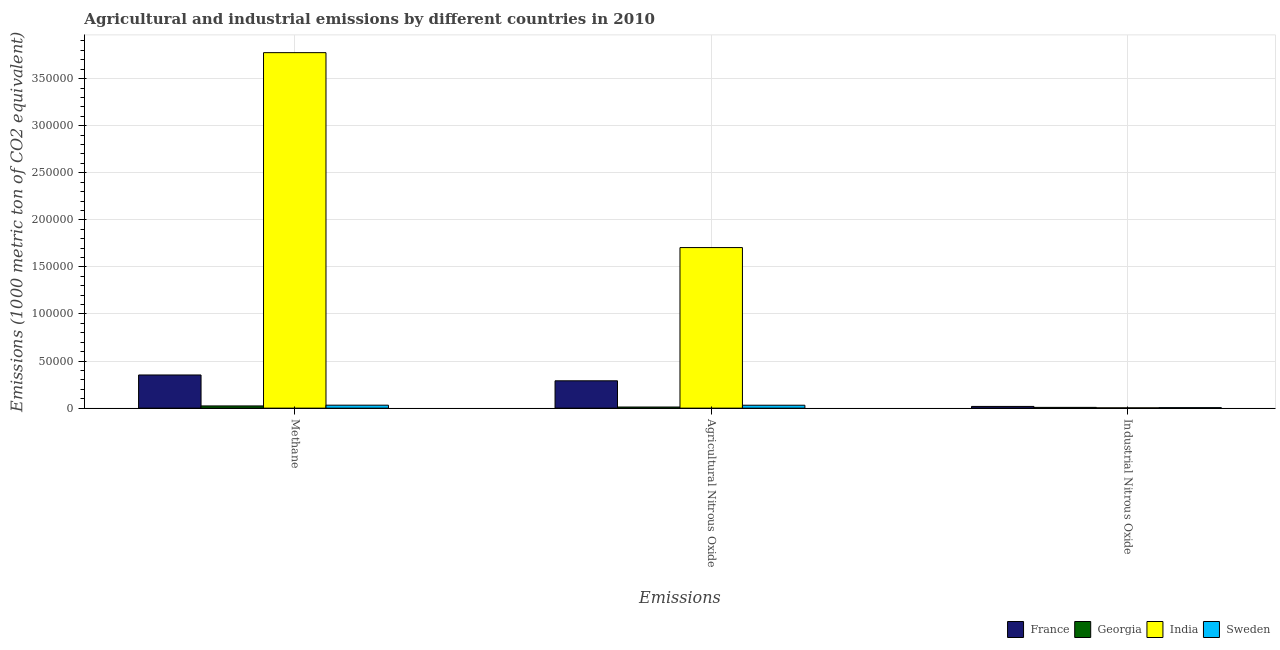How many different coloured bars are there?
Ensure brevity in your answer.  4. How many groups of bars are there?
Your answer should be compact. 3. Are the number of bars on each tick of the X-axis equal?
Offer a very short reply. Yes. How many bars are there on the 1st tick from the left?
Your response must be concise. 4. What is the label of the 2nd group of bars from the left?
Your answer should be compact. Agricultural Nitrous Oxide. What is the amount of agricultural nitrous oxide emissions in Georgia?
Your response must be concise. 1195.6. Across all countries, what is the maximum amount of methane emissions?
Provide a succinct answer. 3.78e+05. Across all countries, what is the minimum amount of industrial nitrous oxide emissions?
Your answer should be compact. 314.9. In which country was the amount of agricultural nitrous oxide emissions minimum?
Keep it short and to the point. Georgia. What is the total amount of agricultural nitrous oxide emissions in the graph?
Offer a very short reply. 2.04e+05. What is the difference between the amount of agricultural nitrous oxide emissions in Sweden and that in France?
Offer a very short reply. -2.59e+04. What is the difference between the amount of agricultural nitrous oxide emissions in Georgia and the amount of industrial nitrous oxide emissions in France?
Give a very brief answer. -633.2. What is the average amount of methane emissions per country?
Offer a terse response. 1.05e+05. What is the difference between the amount of methane emissions and amount of agricultural nitrous oxide emissions in India?
Your answer should be very brief. 2.07e+05. In how many countries, is the amount of industrial nitrous oxide emissions greater than 370000 metric ton?
Make the answer very short. 0. What is the ratio of the amount of methane emissions in France to that in Sweden?
Your answer should be very brief. 11.21. Is the difference between the amount of methane emissions in Sweden and India greater than the difference between the amount of industrial nitrous oxide emissions in Sweden and India?
Keep it short and to the point. No. What is the difference between the highest and the second highest amount of methane emissions?
Give a very brief answer. 3.42e+05. What is the difference between the highest and the lowest amount of industrial nitrous oxide emissions?
Make the answer very short. 1513.9. In how many countries, is the amount of industrial nitrous oxide emissions greater than the average amount of industrial nitrous oxide emissions taken over all countries?
Your response must be concise. 1. How many bars are there?
Offer a very short reply. 12. Are the values on the major ticks of Y-axis written in scientific E-notation?
Your response must be concise. No. Where does the legend appear in the graph?
Give a very brief answer. Bottom right. What is the title of the graph?
Offer a very short reply. Agricultural and industrial emissions by different countries in 2010. What is the label or title of the X-axis?
Offer a terse response. Emissions. What is the label or title of the Y-axis?
Provide a short and direct response. Emissions (1000 metric ton of CO2 equivalent). What is the Emissions (1000 metric ton of CO2 equivalent) of France in Methane?
Offer a very short reply. 3.52e+04. What is the Emissions (1000 metric ton of CO2 equivalent) of Georgia in Methane?
Offer a very short reply. 2363.1. What is the Emissions (1000 metric ton of CO2 equivalent) in India in Methane?
Offer a very short reply. 3.78e+05. What is the Emissions (1000 metric ton of CO2 equivalent) of Sweden in Methane?
Your answer should be very brief. 3144.6. What is the Emissions (1000 metric ton of CO2 equivalent) of France in Agricultural Nitrous Oxide?
Give a very brief answer. 2.90e+04. What is the Emissions (1000 metric ton of CO2 equivalent) in Georgia in Agricultural Nitrous Oxide?
Keep it short and to the point. 1195.6. What is the Emissions (1000 metric ton of CO2 equivalent) of India in Agricultural Nitrous Oxide?
Ensure brevity in your answer.  1.71e+05. What is the Emissions (1000 metric ton of CO2 equivalent) of Sweden in Agricultural Nitrous Oxide?
Provide a succinct answer. 3101. What is the Emissions (1000 metric ton of CO2 equivalent) in France in Industrial Nitrous Oxide?
Ensure brevity in your answer.  1828.8. What is the Emissions (1000 metric ton of CO2 equivalent) of Georgia in Industrial Nitrous Oxide?
Provide a short and direct response. 820.8. What is the Emissions (1000 metric ton of CO2 equivalent) in India in Industrial Nitrous Oxide?
Keep it short and to the point. 314.9. What is the Emissions (1000 metric ton of CO2 equivalent) of Sweden in Industrial Nitrous Oxide?
Your response must be concise. 536.2. Across all Emissions, what is the maximum Emissions (1000 metric ton of CO2 equivalent) in France?
Your answer should be very brief. 3.52e+04. Across all Emissions, what is the maximum Emissions (1000 metric ton of CO2 equivalent) of Georgia?
Keep it short and to the point. 2363.1. Across all Emissions, what is the maximum Emissions (1000 metric ton of CO2 equivalent) of India?
Provide a succinct answer. 3.78e+05. Across all Emissions, what is the maximum Emissions (1000 metric ton of CO2 equivalent) of Sweden?
Your answer should be compact. 3144.6. Across all Emissions, what is the minimum Emissions (1000 metric ton of CO2 equivalent) in France?
Provide a succinct answer. 1828.8. Across all Emissions, what is the minimum Emissions (1000 metric ton of CO2 equivalent) of Georgia?
Your response must be concise. 820.8. Across all Emissions, what is the minimum Emissions (1000 metric ton of CO2 equivalent) in India?
Make the answer very short. 314.9. Across all Emissions, what is the minimum Emissions (1000 metric ton of CO2 equivalent) in Sweden?
Make the answer very short. 536.2. What is the total Emissions (1000 metric ton of CO2 equivalent) of France in the graph?
Your answer should be compact. 6.61e+04. What is the total Emissions (1000 metric ton of CO2 equivalent) in Georgia in the graph?
Ensure brevity in your answer.  4379.5. What is the total Emissions (1000 metric ton of CO2 equivalent) of India in the graph?
Keep it short and to the point. 5.48e+05. What is the total Emissions (1000 metric ton of CO2 equivalent) of Sweden in the graph?
Your answer should be compact. 6781.8. What is the difference between the Emissions (1000 metric ton of CO2 equivalent) in France in Methane and that in Agricultural Nitrous Oxide?
Your response must be concise. 6198.9. What is the difference between the Emissions (1000 metric ton of CO2 equivalent) in Georgia in Methane and that in Agricultural Nitrous Oxide?
Offer a terse response. 1167.5. What is the difference between the Emissions (1000 metric ton of CO2 equivalent) of India in Methane and that in Agricultural Nitrous Oxide?
Keep it short and to the point. 2.07e+05. What is the difference between the Emissions (1000 metric ton of CO2 equivalent) of Sweden in Methane and that in Agricultural Nitrous Oxide?
Provide a succinct answer. 43.6. What is the difference between the Emissions (1000 metric ton of CO2 equivalent) of France in Methane and that in Industrial Nitrous Oxide?
Give a very brief answer. 3.34e+04. What is the difference between the Emissions (1000 metric ton of CO2 equivalent) in Georgia in Methane and that in Industrial Nitrous Oxide?
Your answer should be very brief. 1542.3. What is the difference between the Emissions (1000 metric ton of CO2 equivalent) of India in Methane and that in Industrial Nitrous Oxide?
Your answer should be very brief. 3.77e+05. What is the difference between the Emissions (1000 metric ton of CO2 equivalent) in Sweden in Methane and that in Industrial Nitrous Oxide?
Keep it short and to the point. 2608.4. What is the difference between the Emissions (1000 metric ton of CO2 equivalent) of France in Agricultural Nitrous Oxide and that in Industrial Nitrous Oxide?
Your answer should be very brief. 2.72e+04. What is the difference between the Emissions (1000 metric ton of CO2 equivalent) in Georgia in Agricultural Nitrous Oxide and that in Industrial Nitrous Oxide?
Provide a succinct answer. 374.8. What is the difference between the Emissions (1000 metric ton of CO2 equivalent) of India in Agricultural Nitrous Oxide and that in Industrial Nitrous Oxide?
Make the answer very short. 1.70e+05. What is the difference between the Emissions (1000 metric ton of CO2 equivalent) of Sweden in Agricultural Nitrous Oxide and that in Industrial Nitrous Oxide?
Your response must be concise. 2564.8. What is the difference between the Emissions (1000 metric ton of CO2 equivalent) in France in Methane and the Emissions (1000 metric ton of CO2 equivalent) in Georgia in Agricultural Nitrous Oxide?
Offer a terse response. 3.40e+04. What is the difference between the Emissions (1000 metric ton of CO2 equivalent) in France in Methane and the Emissions (1000 metric ton of CO2 equivalent) in India in Agricultural Nitrous Oxide?
Give a very brief answer. -1.35e+05. What is the difference between the Emissions (1000 metric ton of CO2 equivalent) of France in Methane and the Emissions (1000 metric ton of CO2 equivalent) of Sweden in Agricultural Nitrous Oxide?
Give a very brief answer. 3.21e+04. What is the difference between the Emissions (1000 metric ton of CO2 equivalent) of Georgia in Methane and the Emissions (1000 metric ton of CO2 equivalent) of India in Agricultural Nitrous Oxide?
Provide a succinct answer. -1.68e+05. What is the difference between the Emissions (1000 metric ton of CO2 equivalent) in Georgia in Methane and the Emissions (1000 metric ton of CO2 equivalent) in Sweden in Agricultural Nitrous Oxide?
Provide a short and direct response. -737.9. What is the difference between the Emissions (1000 metric ton of CO2 equivalent) in India in Methane and the Emissions (1000 metric ton of CO2 equivalent) in Sweden in Agricultural Nitrous Oxide?
Offer a terse response. 3.74e+05. What is the difference between the Emissions (1000 metric ton of CO2 equivalent) of France in Methane and the Emissions (1000 metric ton of CO2 equivalent) of Georgia in Industrial Nitrous Oxide?
Offer a terse response. 3.44e+04. What is the difference between the Emissions (1000 metric ton of CO2 equivalent) in France in Methane and the Emissions (1000 metric ton of CO2 equivalent) in India in Industrial Nitrous Oxide?
Offer a very short reply. 3.49e+04. What is the difference between the Emissions (1000 metric ton of CO2 equivalent) in France in Methane and the Emissions (1000 metric ton of CO2 equivalent) in Sweden in Industrial Nitrous Oxide?
Keep it short and to the point. 3.47e+04. What is the difference between the Emissions (1000 metric ton of CO2 equivalent) in Georgia in Methane and the Emissions (1000 metric ton of CO2 equivalent) in India in Industrial Nitrous Oxide?
Offer a very short reply. 2048.2. What is the difference between the Emissions (1000 metric ton of CO2 equivalent) of Georgia in Methane and the Emissions (1000 metric ton of CO2 equivalent) of Sweden in Industrial Nitrous Oxide?
Provide a succinct answer. 1826.9. What is the difference between the Emissions (1000 metric ton of CO2 equivalent) in India in Methane and the Emissions (1000 metric ton of CO2 equivalent) in Sweden in Industrial Nitrous Oxide?
Your response must be concise. 3.77e+05. What is the difference between the Emissions (1000 metric ton of CO2 equivalent) in France in Agricultural Nitrous Oxide and the Emissions (1000 metric ton of CO2 equivalent) in Georgia in Industrial Nitrous Oxide?
Keep it short and to the point. 2.82e+04. What is the difference between the Emissions (1000 metric ton of CO2 equivalent) in France in Agricultural Nitrous Oxide and the Emissions (1000 metric ton of CO2 equivalent) in India in Industrial Nitrous Oxide?
Your answer should be very brief. 2.87e+04. What is the difference between the Emissions (1000 metric ton of CO2 equivalent) of France in Agricultural Nitrous Oxide and the Emissions (1000 metric ton of CO2 equivalent) of Sweden in Industrial Nitrous Oxide?
Your answer should be compact. 2.85e+04. What is the difference between the Emissions (1000 metric ton of CO2 equivalent) in Georgia in Agricultural Nitrous Oxide and the Emissions (1000 metric ton of CO2 equivalent) in India in Industrial Nitrous Oxide?
Make the answer very short. 880.7. What is the difference between the Emissions (1000 metric ton of CO2 equivalent) in Georgia in Agricultural Nitrous Oxide and the Emissions (1000 metric ton of CO2 equivalent) in Sweden in Industrial Nitrous Oxide?
Offer a very short reply. 659.4. What is the difference between the Emissions (1000 metric ton of CO2 equivalent) in India in Agricultural Nitrous Oxide and the Emissions (1000 metric ton of CO2 equivalent) in Sweden in Industrial Nitrous Oxide?
Provide a short and direct response. 1.70e+05. What is the average Emissions (1000 metric ton of CO2 equivalent) of France per Emissions?
Keep it short and to the point. 2.20e+04. What is the average Emissions (1000 metric ton of CO2 equivalent) in Georgia per Emissions?
Offer a terse response. 1459.83. What is the average Emissions (1000 metric ton of CO2 equivalent) of India per Emissions?
Give a very brief answer. 1.83e+05. What is the average Emissions (1000 metric ton of CO2 equivalent) of Sweden per Emissions?
Offer a very short reply. 2260.6. What is the difference between the Emissions (1000 metric ton of CO2 equivalent) in France and Emissions (1000 metric ton of CO2 equivalent) in Georgia in Methane?
Keep it short and to the point. 3.29e+04. What is the difference between the Emissions (1000 metric ton of CO2 equivalent) in France and Emissions (1000 metric ton of CO2 equivalent) in India in Methane?
Offer a very short reply. -3.42e+05. What is the difference between the Emissions (1000 metric ton of CO2 equivalent) of France and Emissions (1000 metric ton of CO2 equivalent) of Sweden in Methane?
Provide a short and direct response. 3.21e+04. What is the difference between the Emissions (1000 metric ton of CO2 equivalent) of Georgia and Emissions (1000 metric ton of CO2 equivalent) of India in Methane?
Provide a short and direct response. -3.75e+05. What is the difference between the Emissions (1000 metric ton of CO2 equivalent) of Georgia and Emissions (1000 metric ton of CO2 equivalent) of Sweden in Methane?
Your answer should be compact. -781.5. What is the difference between the Emissions (1000 metric ton of CO2 equivalent) in India and Emissions (1000 metric ton of CO2 equivalent) in Sweden in Methane?
Offer a very short reply. 3.74e+05. What is the difference between the Emissions (1000 metric ton of CO2 equivalent) of France and Emissions (1000 metric ton of CO2 equivalent) of Georgia in Agricultural Nitrous Oxide?
Keep it short and to the point. 2.78e+04. What is the difference between the Emissions (1000 metric ton of CO2 equivalent) of France and Emissions (1000 metric ton of CO2 equivalent) of India in Agricultural Nitrous Oxide?
Your response must be concise. -1.42e+05. What is the difference between the Emissions (1000 metric ton of CO2 equivalent) of France and Emissions (1000 metric ton of CO2 equivalent) of Sweden in Agricultural Nitrous Oxide?
Offer a terse response. 2.59e+04. What is the difference between the Emissions (1000 metric ton of CO2 equivalent) in Georgia and Emissions (1000 metric ton of CO2 equivalent) in India in Agricultural Nitrous Oxide?
Your response must be concise. -1.69e+05. What is the difference between the Emissions (1000 metric ton of CO2 equivalent) in Georgia and Emissions (1000 metric ton of CO2 equivalent) in Sweden in Agricultural Nitrous Oxide?
Ensure brevity in your answer.  -1905.4. What is the difference between the Emissions (1000 metric ton of CO2 equivalent) in India and Emissions (1000 metric ton of CO2 equivalent) in Sweden in Agricultural Nitrous Oxide?
Provide a succinct answer. 1.67e+05. What is the difference between the Emissions (1000 metric ton of CO2 equivalent) in France and Emissions (1000 metric ton of CO2 equivalent) in Georgia in Industrial Nitrous Oxide?
Your answer should be compact. 1008. What is the difference between the Emissions (1000 metric ton of CO2 equivalent) in France and Emissions (1000 metric ton of CO2 equivalent) in India in Industrial Nitrous Oxide?
Your response must be concise. 1513.9. What is the difference between the Emissions (1000 metric ton of CO2 equivalent) in France and Emissions (1000 metric ton of CO2 equivalent) in Sweden in Industrial Nitrous Oxide?
Offer a terse response. 1292.6. What is the difference between the Emissions (1000 metric ton of CO2 equivalent) in Georgia and Emissions (1000 metric ton of CO2 equivalent) in India in Industrial Nitrous Oxide?
Keep it short and to the point. 505.9. What is the difference between the Emissions (1000 metric ton of CO2 equivalent) in Georgia and Emissions (1000 metric ton of CO2 equivalent) in Sweden in Industrial Nitrous Oxide?
Your answer should be compact. 284.6. What is the difference between the Emissions (1000 metric ton of CO2 equivalent) in India and Emissions (1000 metric ton of CO2 equivalent) in Sweden in Industrial Nitrous Oxide?
Make the answer very short. -221.3. What is the ratio of the Emissions (1000 metric ton of CO2 equivalent) of France in Methane to that in Agricultural Nitrous Oxide?
Your response must be concise. 1.21. What is the ratio of the Emissions (1000 metric ton of CO2 equivalent) of Georgia in Methane to that in Agricultural Nitrous Oxide?
Make the answer very short. 1.98. What is the ratio of the Emissions (1000 metric ton of CO2 equivalent) of India in Methane to that in Agricultural Nitrous Oxide?
Your answer should be compact. 2.21. What is the ratio of the Emissions (1000 metric ton of CO2 equivalent) of Sweden in Methane to that in Agricultural Nitrous Oxide?
Your answer should be very brief. 1.01. What is the ratio of the Emissions (1000 metric ton of CO2 equivalent) in France in Methane to that in Industrial Nitrous Oxide?
Give a very brief answer. 19.27. What is the ratio of the Emissions (1000 metric ton of CO2 equivalent) of Georgia in Methane to that in Industrial Nitrous Oxide?
Provide a succinct answer. 2.88. What is the ratio of the Emissions (1000 metric ton of CO2 equivalent) of India in Methane to that in Industrial Nitrous Oxide?
Offer a terse response. 1199.08. What is the ratio of the Emissions (1000 metric ton of CO2 equivalent) in Sweden in Methane to that in Industrial Nitrous Oxide?
Your response must be concise. 5.86. What is the ratio of the Emissions (1000 metric ton of CO2 equivalent) of France in Agricultural Nitrous Oxide to that in Industrial Nitrous Oxide?
Your response must be concise. 15.88. What is the ratio of the Emissions (1000 metric ton of CO2 equivalent) of Georgia in Agricultural Nitrous Oxide to that in Industrial Nitrous Oxide?
Provide a succinct answer. 1.46. What is the ratio of the Emissions (1000 metric ton of CO2 equivalent) of India in Agricultural Nitrous Oxide to that in Industrial Nitrous Oxide?
Give a very brief answer. 541.6. What is the ratio of the Emissions (1000 metric ton of CO2 equivalent) of Sweden in Agricultural Nitrous Oxide to that in Industrial Nitrous Oxide?
Ensure brevity in your answer.  5.78. What is the difference between the highest and the second highest Emissions (1000 metric ton of CO2 equivalent) of France?
Offer a very short reply. 6198.9. What is the difference between the highest and the second highest Emissions (1000 metric ton of CO2 equivalent) in Georgia?
Your answer should be very brief. 1167.5. What is the difference between the highest and the second highest Emissions (1000 metric ton of CO2 equivalent) of India?
Give a very brief answer. 2.07e+05. What is the difference between the highest and the second highest Emissions (1000 metric ton of CO2 equivalent) of Sweden?
Provide a short and direct response. 43.6. What is the difference between the highest and the lowest Emissions (1000 metric ton of CO2 equivalent) of France?
Your answer should be very brief. 3.34e+04. What is the difference between the highest and the lowest Emissions (1000 metric ton of CO2 equivalent) of Georgia?
Offer a very short reply. 1542.3. What is the difference between the highest and the lowest Emissions (1000 metric ton of CO2 equivalent) in India?
Give a very brief answer. 3.77e+05. What is the difference between the highest and the lowest Emissions (1000 metric ton of CO2 equivalent) of Sweden?
Provide a short and direct response. 2608.4. 